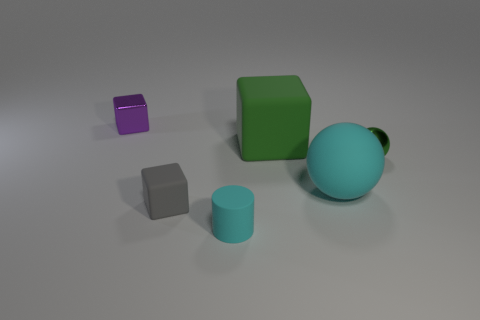Add 1 red matte objects. How many objects exist? 7 Subtract all cylinders. How many objects are left? 5 Subtract 0 brown balls. How many objects are left? 6 Subtract all rubber things. Subtract all brown objects. How many objects are left? 2 Add 3 green blocks. How many green blocks are left? 4 Add 3 small shiny objects. How many small shiny objects exist? 5 